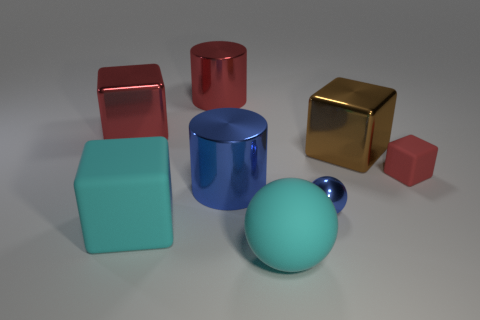Subtract all red blocks. How many were subtracted if there are1red blocks left? 1 Subtract all blue spheres. Subtract all brown cubes. How many spheres are left? 1 Add 2 small yellow metallic spheres. How many objects exist? 10 Subtract all balls. How many objects are left? 6 Add 4 large red blocks. How many large red blocks are left? 5 Add 6 big red cubes. How many big red cubes exist? 7 Subtract 2 red cubes. How many objects are left? 6 Subtract all large cubes. Subtract all large purple cylinders. How many objects are left? 5 